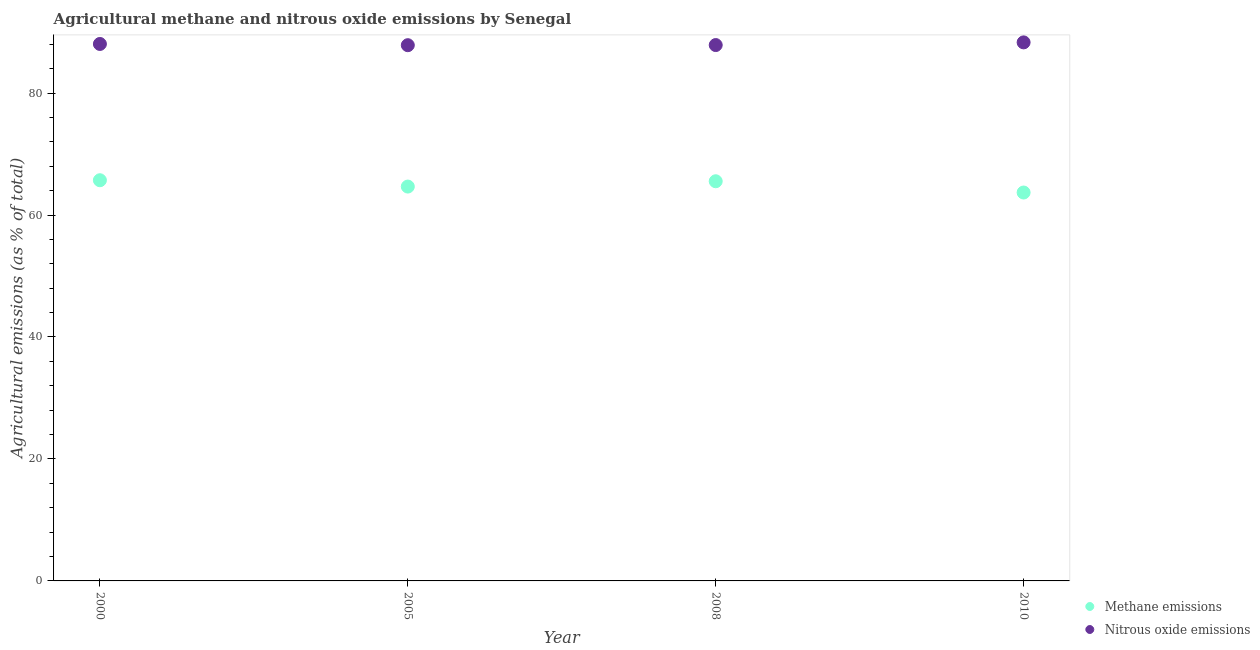Is the number of dotlines equal to the number of legend labels?
Ensure brevity in your answer.  Yes. What is the amount of methane emissions in 2010?
Your response must be concise. 63.69. Across all years, what is the maximum amount of methane emissions?
Give a very brief answer. 65.71. Across all years, what is the minimum amount of methane emissions?
Provide a succinct answer. 63.69. In which year was the amount of nitrous oxide emissions minimum?
Offer a very short reply. 2005. What is the total amount of nitrous oxide emissions in the graph?
Give a very brief answer. 352.09. What is the difference between the amount of nitrous oxide emissions in 2000 and that in 2010?
Offer a terse response. -0.26. What is the difference between the amount of nitrous oxide emissions in 2010 and the amount of methane emissions in 2005?
Give a very brief answer. 23.64. What is the average amount of nitrous oxide emissions per year?
Ensure brevity in your answer.  88.02. In the year 2008, what is the difference between the amount of nitrous oxide emissions and amount of methane emissions?
Provide a succinct answer. 22.33. In how many years, is the amount of methane emissions greater than 24 %?
Ensure brevity in your answer.  4. What is the ratio of the amount of nitrous oxide emissions in 2005 to that in 2010?
Ensure brevity in your answer.  0.99. Is the difference between the amount of nitrous oxide emissions in 2000 and 2010 greater than the difference between the amount of methane emissions in 2000 and 2010?
Offer a terse response. No. What is the difference between the highest and the second highest amount of methane emissions?
Offer a very short reply. 0.17. What is the difference between the highest and the lowest amount of nitrous oxide emissions?
Your answer should be compact. 0.46. Is the sum of the amount of methane emissions in 2000 and 2010 greater than the maximum amount of nitrous oxide emissions across all years?
Make the answer very short. Yes. Does the amount of nitrous oxide emissions monotonically increase over the years?
Provide a short and direct response. No. Is the amount of nitrous oxide emissions strictly less than the amount of methane emissions over the years?
Ensure brevity in your answer.  No. Does the graph contain grids?
Make the answer very short. No. What is the title of the graph?
Give a very brief answer. Agricultural methane and nitrous oxide emissions by Senegal. What is the label or title of the Y-axis?
Your answer should be compact. Agricultural emissions (as % of total). What is the Agricultural emissions (as % of total) in Methane emissions in 2000?
Your answer should be very brief. 65.71. What is the Agricultural emissions (as % of total) of Nitrous oxide emissions in 2000?
Keep it short and to the point. 88.05. What is the Agricultural emissions (as % of total) of Methane emissions in 2005?
Offer a very short reply. 64.67. What is the Agricultural emissions (as % of total) in Nitrous oxide emissions in 2005?
Provide a succinct answer. 87.85. What is the Agricultural emissions (as % of total) in Methane emissions in 2008?
Your response must be concise. 65.54. What is the Agricultural emissions (as % of total) of Nitrous oxide emissions in 2008?
Your answer should be very brief. 87.87. What is the Agricultural emissions (as % of total) of Methane emissions in 2010?
Make the answer very short. 63.69. What is the Agricultural emissions (as % of total) of Nitrous oxide emissions in 2010?
Give a very brief answer. 88.31. Across all years, what is the maximum Agricultural emissions (as % of total) of Methane emissions?
Give a very brief answer. 65.71. Across all years, what is the maximum Agricultural emissions (as % of total) in Nitrous oxide emissions?
Your answer should be compact. 88.31. Across all years, what is the minimum Agricultural emissions (as % of total) in Methane emissions?
Keep it short and to the point. 63.69. Across all years, what is the minimum Agricultural emissions (as % of total) of Nitrous oxide emissions?
Provide a succinct answer. 87.85. What is the total Agricultural emissions (as % of total) of Methane emissions in the graph?
Keep it short and to the point. 259.6. What is the total Agricultural emissions (as % of total) in Nitrous oxide emissions in the graph?
Give a very brief answer. 352.09. What is the difference between the Agricultural emissions (as % of total) in Methane emissions in 2000 and that in 2005?
Provide a short and direct response. 1.04. What is the difference between the Agricultural emissions (as % of total) of Nitrous oxide emissions in 2000 and that in 2005?
Keep it short and to the point. 0.2. What is the difference between the Agricultural emissions (as % of total) of Methane emissions in 2000 and that in 2008?
Make the answer very short. 0.17. What is the difference between the Agricultural emissions (as % of total) in Nitrous oxide emissions in 2000 and that in 2008?
Your answer should be very brief. 0.18. What is the difference between the Agricultural emissions (as % of total) in Methane emissions in 2000 and that in 2010?
Offer a terse response. 2.01. What is the difference between the Agricultural emissions (as % of total) in Nitrous oxide emissions in 2000 and that in 2010?
Provide a short and direct response. -0.26. What is the difference between the Agricultural emissions (as % of total) in Methane emissions in 2005 and that in 2008?
Offer a very short reply. -0.87. What is the difference between the Agricultural emissions (as % of total) in Nitrous oxide emissions in 2005 and that in 2008?
Keep it short and to the point. -0.02. What is the difference between the Agricultural emissions (as % of total) of Methane emissions in 2005 and that in 2010?
Offer a terse response. 0.98. What is the difference between the Agricultural emissions (as % of total) of Nitrous oxide emissions in 2005 and that in 2010?
Your answer should be very brief. -0.46. What is the difference between the Agricultural emissions (as % of total) of Methane emissions in 2008 and that in 2010?
Provide a succinct answer. 1.85. What is the difference between the Agricultural emissions (as % of total) of Nitrous oxide emissions in 2008 and that in 2010?
Keep it short and to the point. -0.44. What is the difference between the Agricultural emissions (as % of total) of Methane emissions in 2000 and the Agricultural emissions (as % of total) of Nitrous oxide emissions in 2005?
Offer a terse response. -22.15. What is the difference between the Agricultural emissions (as % of total) in Methane emissions in 2000 and the Agricultural emissions (as % of total) in Nitrous oxide emissions in 2008?
Your response must be concise. -22.17. What is the difference between the Agricultural emissions (as % of total) in Methane emissions in 2000 and the Agricultural emissions (as % of total) in Nitrous oxide emissions in 2010?
Your answer should be compact. -22.61. What is the difference between the Agricultural emissions (as % of total) of Methane emissions in 2005 and the Agricultural emissions (as % of total) of Nitrous oxide emissions in 2008?
Give a very brief answer. -23.21. What is the difference between the Agricultural emissions (as % of total) of Methane emissions in 2005 and the Agricultural emissions (as % of total) of Nitrous oxide emissions in 2010?
Ensure brevity in your answer.  -23.64. What is the difference between the Agricultural emissions (as % of total) in Methane emissions in 2008 and the Agricultural emissions (as % of total) in Nitrous oxide emissions in 2010?
Provide a succinct answer. -22.77. What is the average Agricultural emissions (as % of total) in Methane emissions per year?
Ensure brevity in your answer.  64.9. What is the average Agricultural emissions (as % of total) of Nitrous oxide emissions per year?
Your response must be concise. 88.02. In the year 2000, what is the difference between the Agricultural emissions (as % of total) in Methane emissions and Agricultural emissions (as % of total) in Nitrous oxide emissions?
Offer a terse response. -22.35. In the year 2005, what is the difference between the Agricultural emissions (as % of total) of Methane emissions and Agricultural emissions (as % of total) of Nitrous oxide emissions?
Make the answer very short. -23.18. In the year 2008, what is the difference between the Agricultural emissions (as % of total) in Methane emissions and Agricultural emissions (as % of total) in Nitrous oxide emissions?
Make the answer very short. -22.33. In the year 2010, what is the difference between the Agricultural emissions (as % of total) in Methane emissions and Agricultural emissions (as % of total) in Nitrous oxide emissions?
Offer a very short reply. -24.62. What is the ratio of the Agricultural emissions (as % of total) of Methane emissions in 2000 to that in 2005?
Your answer should be very brief. 1.02. What is the ratio of the Agricultural emissions (as % of total) of Methane emissions in 2000 to that in 2008?
Give a very brief answer. 1. What is the ratio of the Agricultural emissions (as % of total) in Nitrous oxide emissions in 2000 to that in 2008?
Your response must be concise. 1. What is the ratio of the Agricultural emissions (as % of total) in Methane emissions in 2000 to that in 2010?
Your answer should be compact. 1.03. What is the ratio of the Agricultural emissions (as % of total) in Nitrous oxide emissions in 2000 to that in 2010?
Your answer should be compact. 1. What is the ratio of the Agricultural emissions (as % of total) in Methane emissions in 2005 to that in 2008?
Make the answer very short. 0.99. What is the ratio of the Agricultural emissions (as % of total) of Nitrous oxide emissions in 2005 to that in 2008?
Make the answer very short. 1. What is the ratio of the Agricultural emissions (as % of total) in Methane emissions in 2005 to that in 2010?
Keep it short and to the point. 1.02. What is the ratio of the Agricultural emissions (as % of total) in Methane emissions in 2008 to that in 2010?
Your answer should be very brief. 1.03. What is the difference between the highest and the second highest Agricultural emissions (as % of total) in Methane emissions?
Give a very brief answer. 0.17. What is the difference between the highest and the second highest Agricultural emissions (as % of total) in Nitrous oxide emissions?
Your answer should be very brief. 0.26. What is the difference between the highest and the lowest Agricultural emissions (as % of total) in Methane emissions?
Provide a succinct answer. 2.01. What is the difference between the highest and the lowest Agricultural emissions (as % of total) of Nitrous oxide emissions?
Your answer should be very brief. 0.46. 